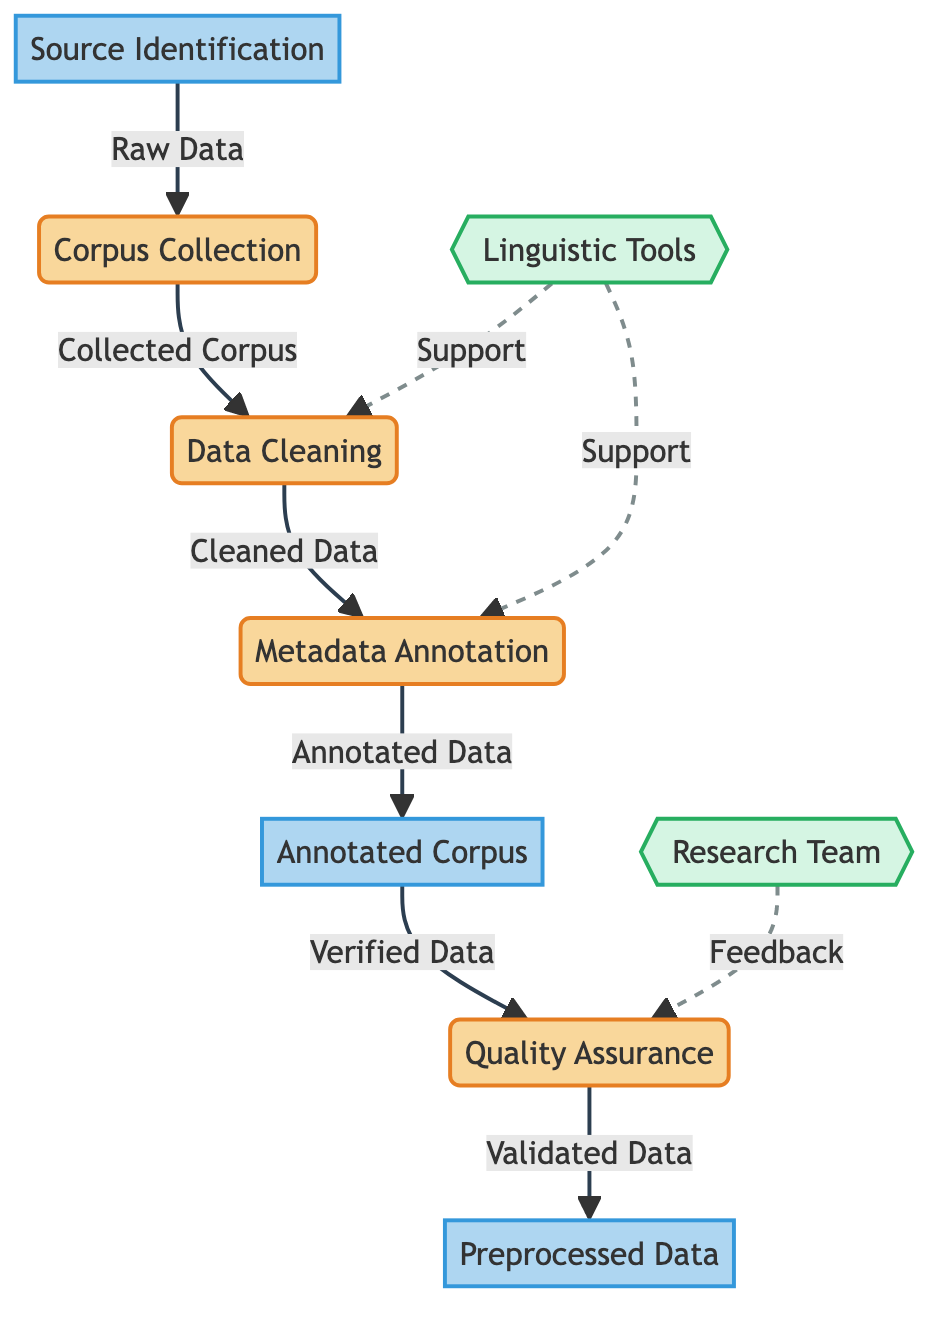What is the first process in the pipeline? The first process, as indicated in the diagram, is "Corpus Collection." It is the initial step where data is collected from various sources.
Answer: Corpus Collection How many external entities are present in the diagram? The diagram contains two external entities, which are "Linguistic Tools" and "Research Team."
Answer: 2 What type of data store is "Annotated Corpus"? "Annotated Corpus" is classified as a data store according to the elements labeled in the diagram.
Answer: data store What is the output of the "Quality Assurance" process? The output of the "Quality Assurance" process is "Validated Data," which is verified data ready for further use.
Answer: Validated Data Which process receives input from the "Annotated Corpus"? The "Quality Assurance" process receives input from the "Annotated Corpus," where the verified data is processed.
Answer: Quality Assurance What type of relationship is shown between "Linguistic Tools" and the processes it supports? The relationship is depicted as a dashed line, indicating a supporting role where "Linguistic Tools" provide assistance to the processes "Data Cleaning" and "Metadata Annotation."
Answer: Support What follows after "Metadata Annotation" in the diagram? After "Metadata Annotation," the next step is "Annotated Corpus," where the annotated data is stored.
Answer: Annotated Corpus What is the main function of the "Research Team" in this pipeline? The main function of the "Research Team" is to provide feedback during the "Quality Assurance" process, ensuring the data meets required standards.
Answer: Feedback How does "Data Cleaning" relate to the "Corpus Collection"? "Data Cleaning" directly follows "Corpus Collection" in the flow, being the next step where the collected corpus is cleaned.
Answer: Next Step 